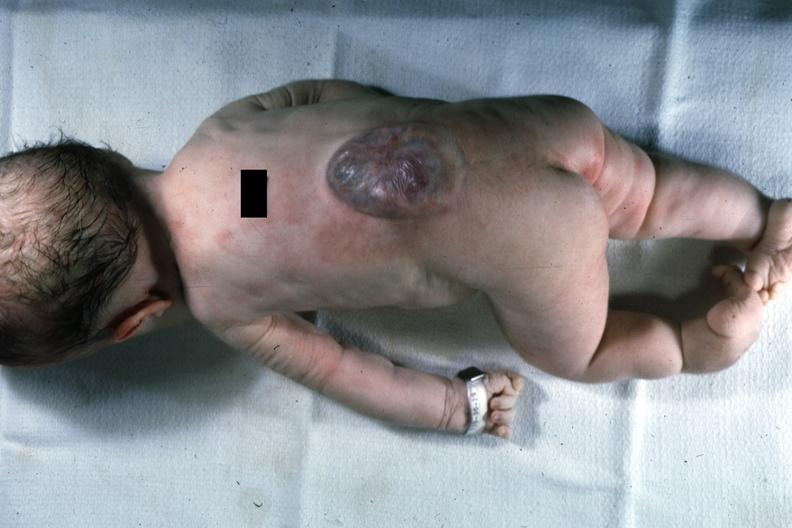s spina bifida present?
Answer the question using a single word or phrase. Yes 